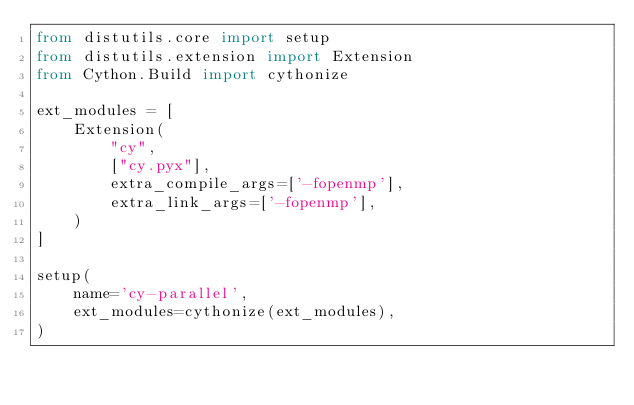<code> <loc_0><loc_0><loc_500><loc_500><_Python_>from distutils.core import setup
from distutils.extension import Extension
from Cython.Build import cythonize

ext_modules = [
    Extension(
        "cy",
        ["cy.pyx"],
        extra_compile_args=['-fopenmp'],
        extra_link_args=['-fopenmp'],
    )
]

setup(
    name='cy-parallel',
    ext_modules=cythonize(ext_modules),
)
</code> 